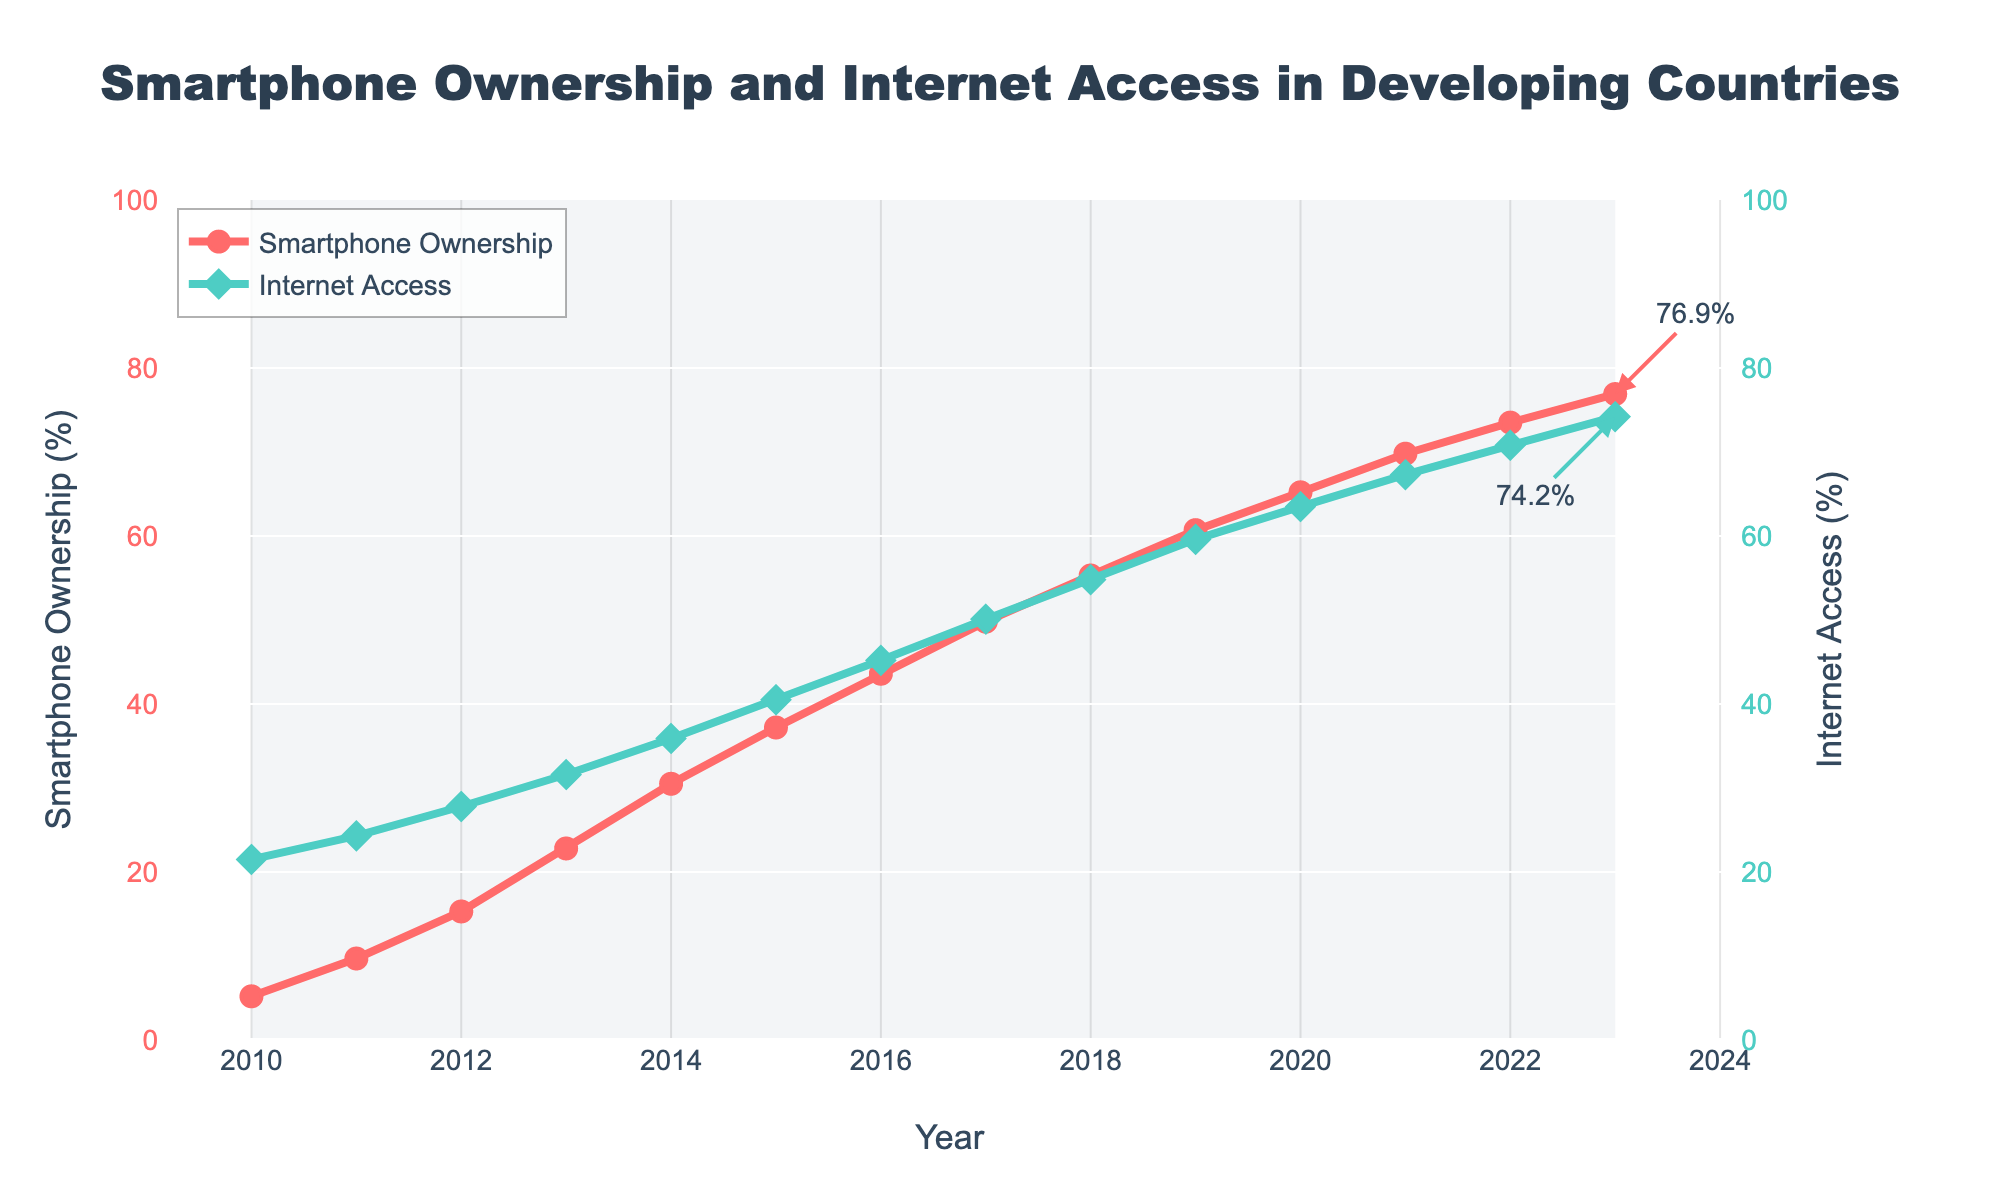What's the overall trend for smartphone ownership from 2010 to 2023? From 2010 to 2023, smartphone ownership shows a general upward trend, increasing each year from 5.2% in 2010 to 76.9% in 2023.
Answer: Increasing How does internet access change over the period from 2010 to 2023? Internet access also shows an upward trend over the period, starting at 21.5% in 2010 and rising to 74.2% in 2023.
Answer: Increasing In which year did smartphone ownership first surpass 50%? By examining the figure, smartphone ownership first surpasses 50% in 2017, where it is recorded at 49.8%.
Answer: 2017 Compare the rate of increase in smartphone ownership between 2010 and 2015 and between 2015 and 2020. Which period had a higher rate of increase? For 2010-2015, the increase is 32% (37.2% - 5.2%) over 5 years (~6.4% per year). For 2015-2020, the increase is 28% (65.2% - 37.2%) over 5 years (~5.6% per year). The period 2010-2015 had a higher rate of increase.
Answer: 2010-2015 In what year are the internet access rates and smartphone ownership rates approximately equal? Around 2019, the internet access rate is 59.6% while smartphone ownership is 60.7%, which are approximately equal.
Answer: 2019 Which year shows the fastest growth in internet access? The steepest increase in internet access rate appears to be between 2011 and 2012, where the rate increases from 24.3% to 27.8%, a growth of 3.5%.
Answer: 2012 What is the difference in internet access rates between 2020 and 2021? The difference is calculated by subtracting the 2020 rate (63.5%) from the 2021 rate (67.3%), yielding 3.8%.
Answer: 3.8% Which line color represents internet access rates in the figure? The green line represents the internet access rates in the figure.
Answer: Green What visual feature highlights the data points for smartphone ownership in the figure? The data points for smartphone ownership are highlighted with red circular markers along the red line.
Answer: Red circular markers 